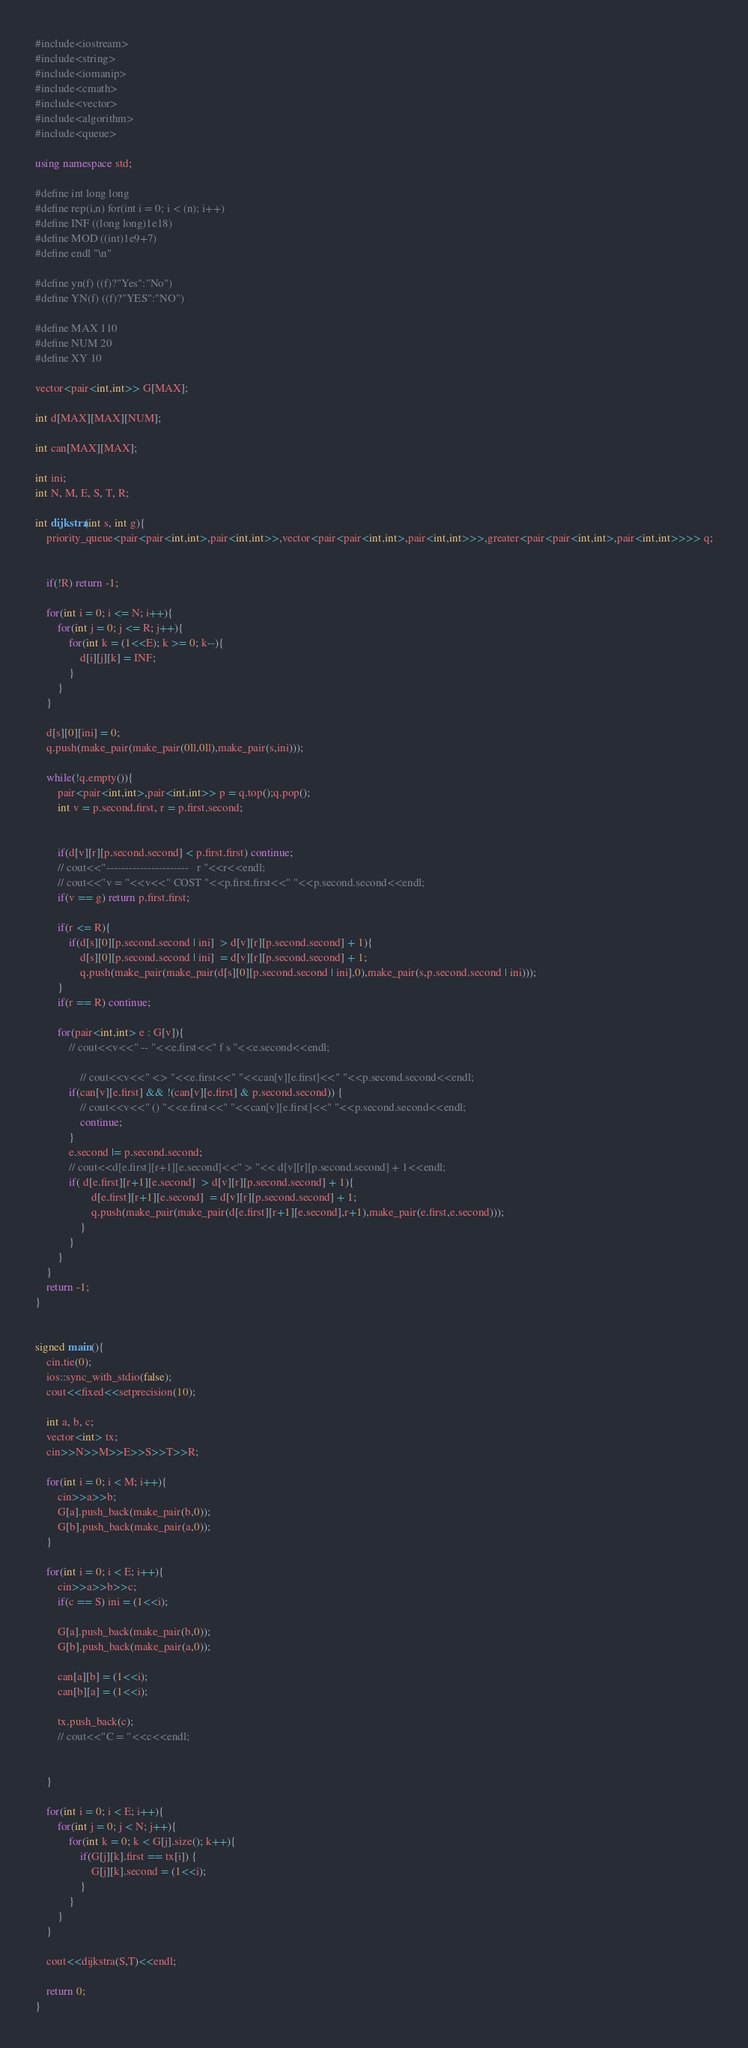Convert code to text. <code><loc_0><loc_0><loc_500><loc_500><_C++_>#include<iostream>
#include<string>
#include<iomanip>
#include<cmath>
#include<vector>
#include<algorithm>
#include<queue>

using namespace std;

#define int long long
#define rep(i,n) for(int i = 0; i < (n); i++)
#define INF ((long long)1e18)
#define MOD ((int)1e9+7)
#define endl "\n"

#define yn(f) ((f)?"Yes":"No")
#define YN(f) ((f)?"YES":"NO")

#define MAX 110
#define NUM 20
#define XY 10

vector<pair<int,int>> G[MAX];

int d[MAX][MAX][NUM];

int can[MAX][MAX];

int ini;
int N, M, E, S, T, R;

int dijkstra(int s, int g){
	priority_queue<pair<pair<int,int>,pair<int,int>>,vector<pair<pair<int,int>,pair<int,int>>>,greater<pair<pair<int,int>,pair<int,int>>>> q;
	
	
	if(!R) return -1;
	
	for(int i = 0; i <= N; i++){
		for(int j = 0; j <= R; j++){
			for(int k = (1<<E); k >= 0; k--){
				d[i][j][k] = INF;
			}
		}
	}
	
	d[s][0][ini] = 0;
	q.push(make_pair(make_pair(0ll,0ll),make_pair(s,ini)));
	
	while(!q.empty()){
		pair<pair<int,int>,pair<int,int>> p = q.top();q.pop();
		int v = p.second.first, r = p.first.second;
		
		
		if(d[v][r][p.second.second] < p.first.first) continue;
		// cout<<"----------------------   r "<<r<<endl;
		// cout<<"v = "<<v<<" COST "<<p.first.first<<" "<<p.second.second<<endl;
		if(v == g) return p.first.first;
		
		if(r <= R){
			if(d[s][0][p.second.second | ini]  > d[v][r][p.second.second] + 1){
				d[s][0][p.second.second | ini]  = d[v][r][p.second.second] + 1;		
				q.push(make_pair(make_pair(d[s][0][p.second.second | ini],0),make_pair(s,p.second.second | ini)));
		}
		if(r == R) continue;
		
		for(pair<int,int> e : G[v]){
			// cout<<v<<" -- "<<e.first<<" f s "<<e.second<<endl;
			
				// cout<<v<<" <> "<<e.first<<" "<<can[v][e.first]<<" "<<p.second.second<<endl;
			if(can[v][e.first] && !(can[v][e.first] & p.second.second)) {
				// cout<<v<<" () "<<e.first<<" "<<can[v][e.first]<<" "<<p.second.second<<endl;
				continue;
			}
			e.second |= p.second.second;
			// cout<<d[e.first][r+1][e.second]<<" > "<< d[v][r][p.second.second] + 1<<endl;
			if( d[e.first][r+1][e.second]  > d[v][r][p.second.second] + 1){
					d[e.first][r+1][e.second]  = d[v][r][p.second.second] + 1;
					q.push(make_pair(make_pair(d[e.first][r+1][e.second],r+1),make_pair(e.first,e.second)));
				}
			}
		}
	}
	return -1;
}


signed main(){
	cin.tie(0);
	ios::sync_with_stdio(false);
	cout<<fixed<<setprecision(10);
	
	int a, b, c;
	vector<int> tx;
	cin>>N>>M>>E>>S>>T>>R;
	
	for(int i = 0; i < M; i++){
		cin>>a>>b;
		G[a].push_back(make_pair(b,0));
		G[b].push_back(make_pair(a,0));
	}
	
	for(int i = 0; i < E; i++){
		cin>>a>>b>>c;
		if(c == S) ini = (1<<i);
		
		G[a].push_back(make_pair(b,0));
		G[b].push_back(make_pair(a,0));
		
		can[a][b] = (1<<i);
		can[b][a] = (1<<i);
		
		tx.push_back(c);
		// cout<<"C = "<<c<<endl;
		
		
	}
	
	for(int i = 0; i < E; i++){
		for(int j = 0; j < N; j++){
			for(int k = 0; k < G[j].size(); k++){
				if(G[j][k].first == tx[i]) {
					G[j][k].second = (1<<i);
				}
			}
		}
	}
	
	cout<<dijkstra(S,T)<<endl;
	
	return 0;
}
</code> 